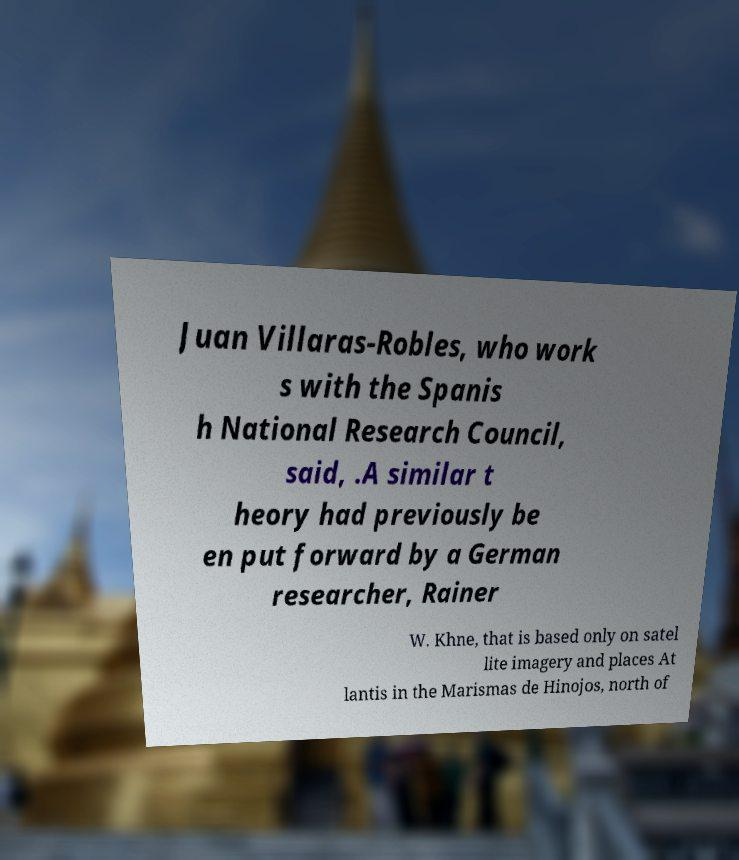I need the written content from this picture converted into text. Can you do that? Juan Villaras-Robles, who work s with the Spanis h National Research Council, said, .A similar t heory had previously be en put forward by a German researcher, Rainer W. Khne, that is based only on satel lite imagery and places At lantis in the Marismas de Hinojos, north of 